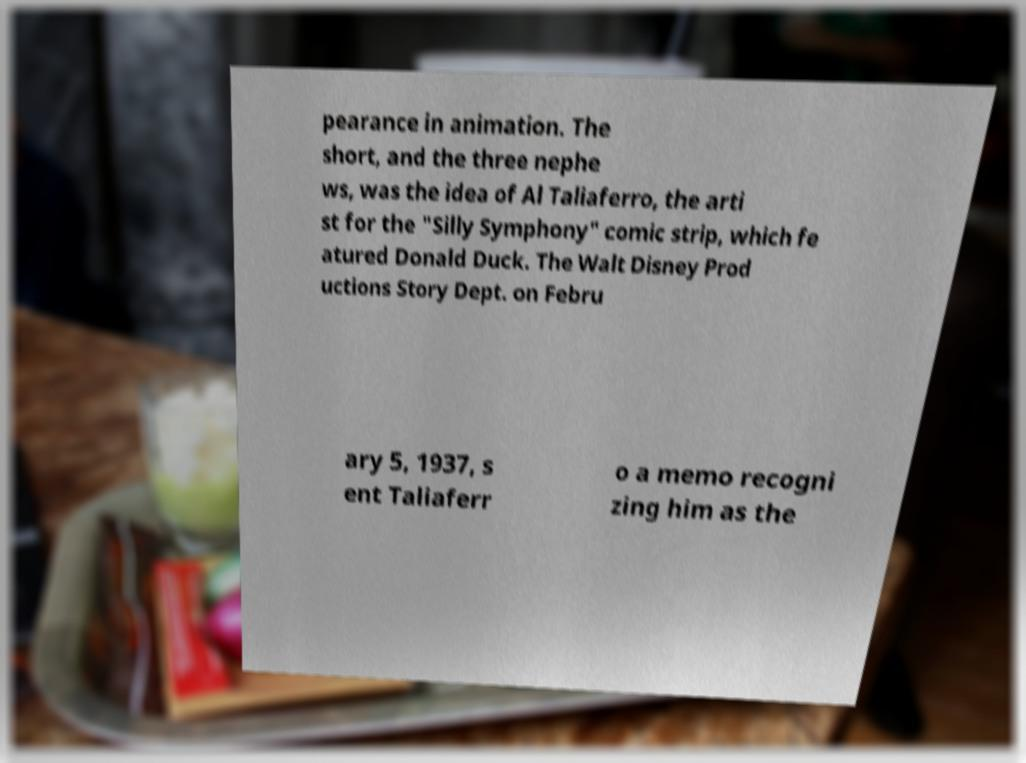There's text embedded in this image that I need extracted. Can you transcribe it verbatim? pearance in animation. The short, and the three nephe ws, was the idea of Al Taliaferro, the arti st for the "Silly Symphony" comic strip, which fe atured Donald Duck. The Walt Disney Prod uctions Story Dept. on Febru ary 5, 1937, s ent Taliaferr o a memo recogni zing him as the 